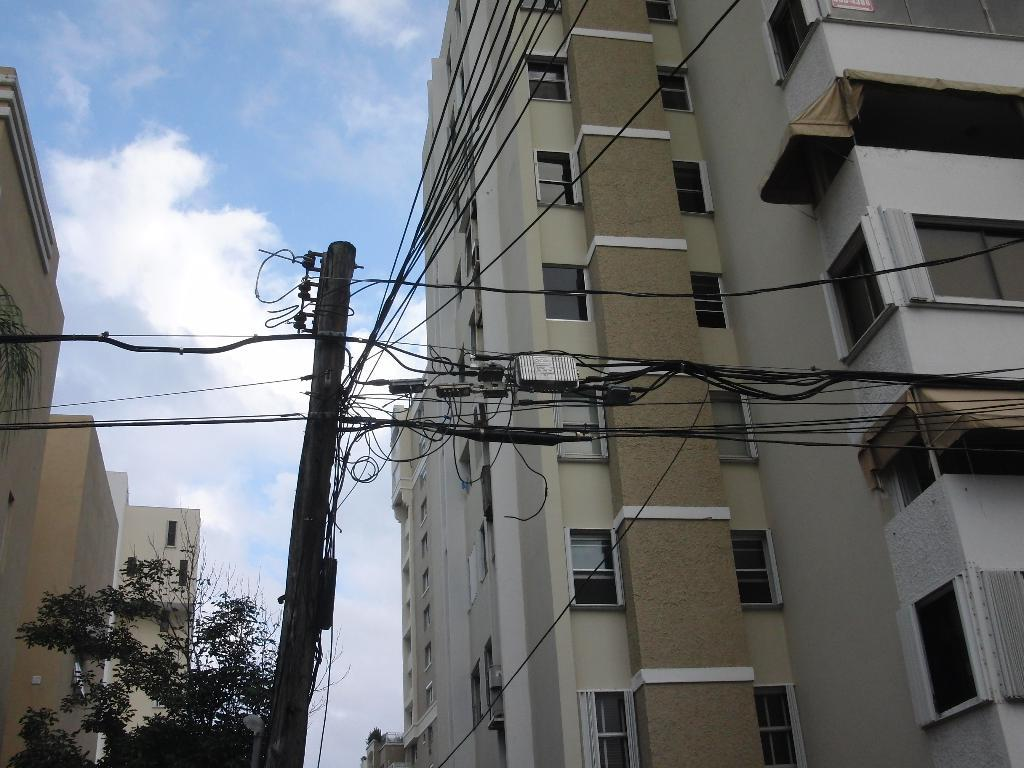What type of structures are present in the image? There are buildings in the image. What feature do the buildings have? The buildings have windows. What else can be seen in the image besides the buildings? There is a pole in the image. What is attached to the pole? There are wires attached to the pole. What is the governor doing in the image? There is no governor present in the image. How quiet is the hall in the image? There is no hall mentioned in the image, so it's not possible to determine its level of quietness. 